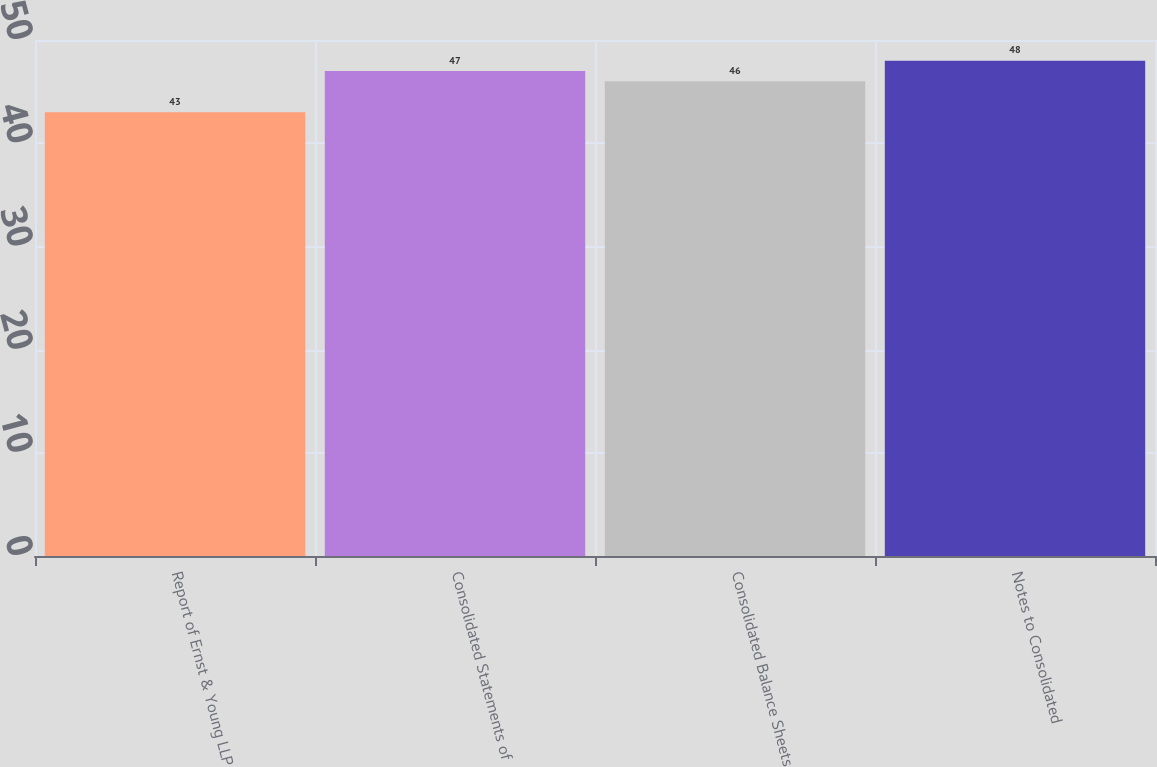Convert chart. <chart><loc_0><loc_0><loc_500><loc_500><bar_chart><fcel>Report of Ernst & Young LLP<fcel>Consolidated Statements of<fcel>Consolidated Balance Sheets<fcel>Notes to Consolidated<nl><fcel>43<fcel>47<fcel>46<fcel>48<nl></chart> 